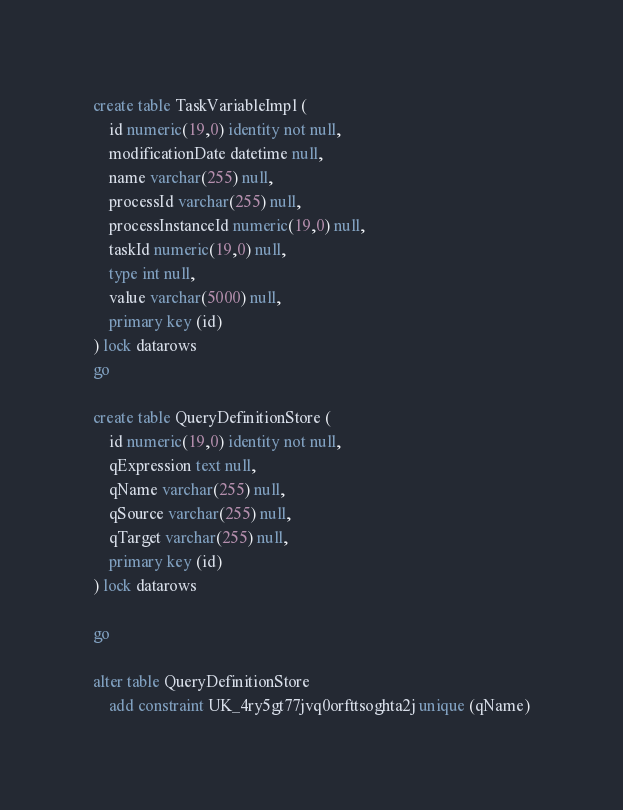Convert code to text. <code><loc_0><loc_0><loc_500><loc_500><_SQL_>create table TaskVariableImpl (
    id numeric(19,0) identity not null,
    modificationDate datetime null,
    name varchar(255) null,
    processId varchar(255) null,
    processInstanceId numeric(19,0) null,
    taskId numeric(19,0) null,
    type int null,
    value varchar(5000) null,
    primary key (id)
) lock datarows
go

create table QueryDefinitionStore (
    id numeric(19,0) identity not null,
    qExpression text null,
    qName varchar(255) null,
    qSource varchar(255) null,
    qTarget varchar(255) null,
    primary key (id)
) lock datarows

go

alter table QueryDefinitionStore 
    add constraint UK_4ry5gt77jvq0orfttsoghta2j unique (qName)</code> 